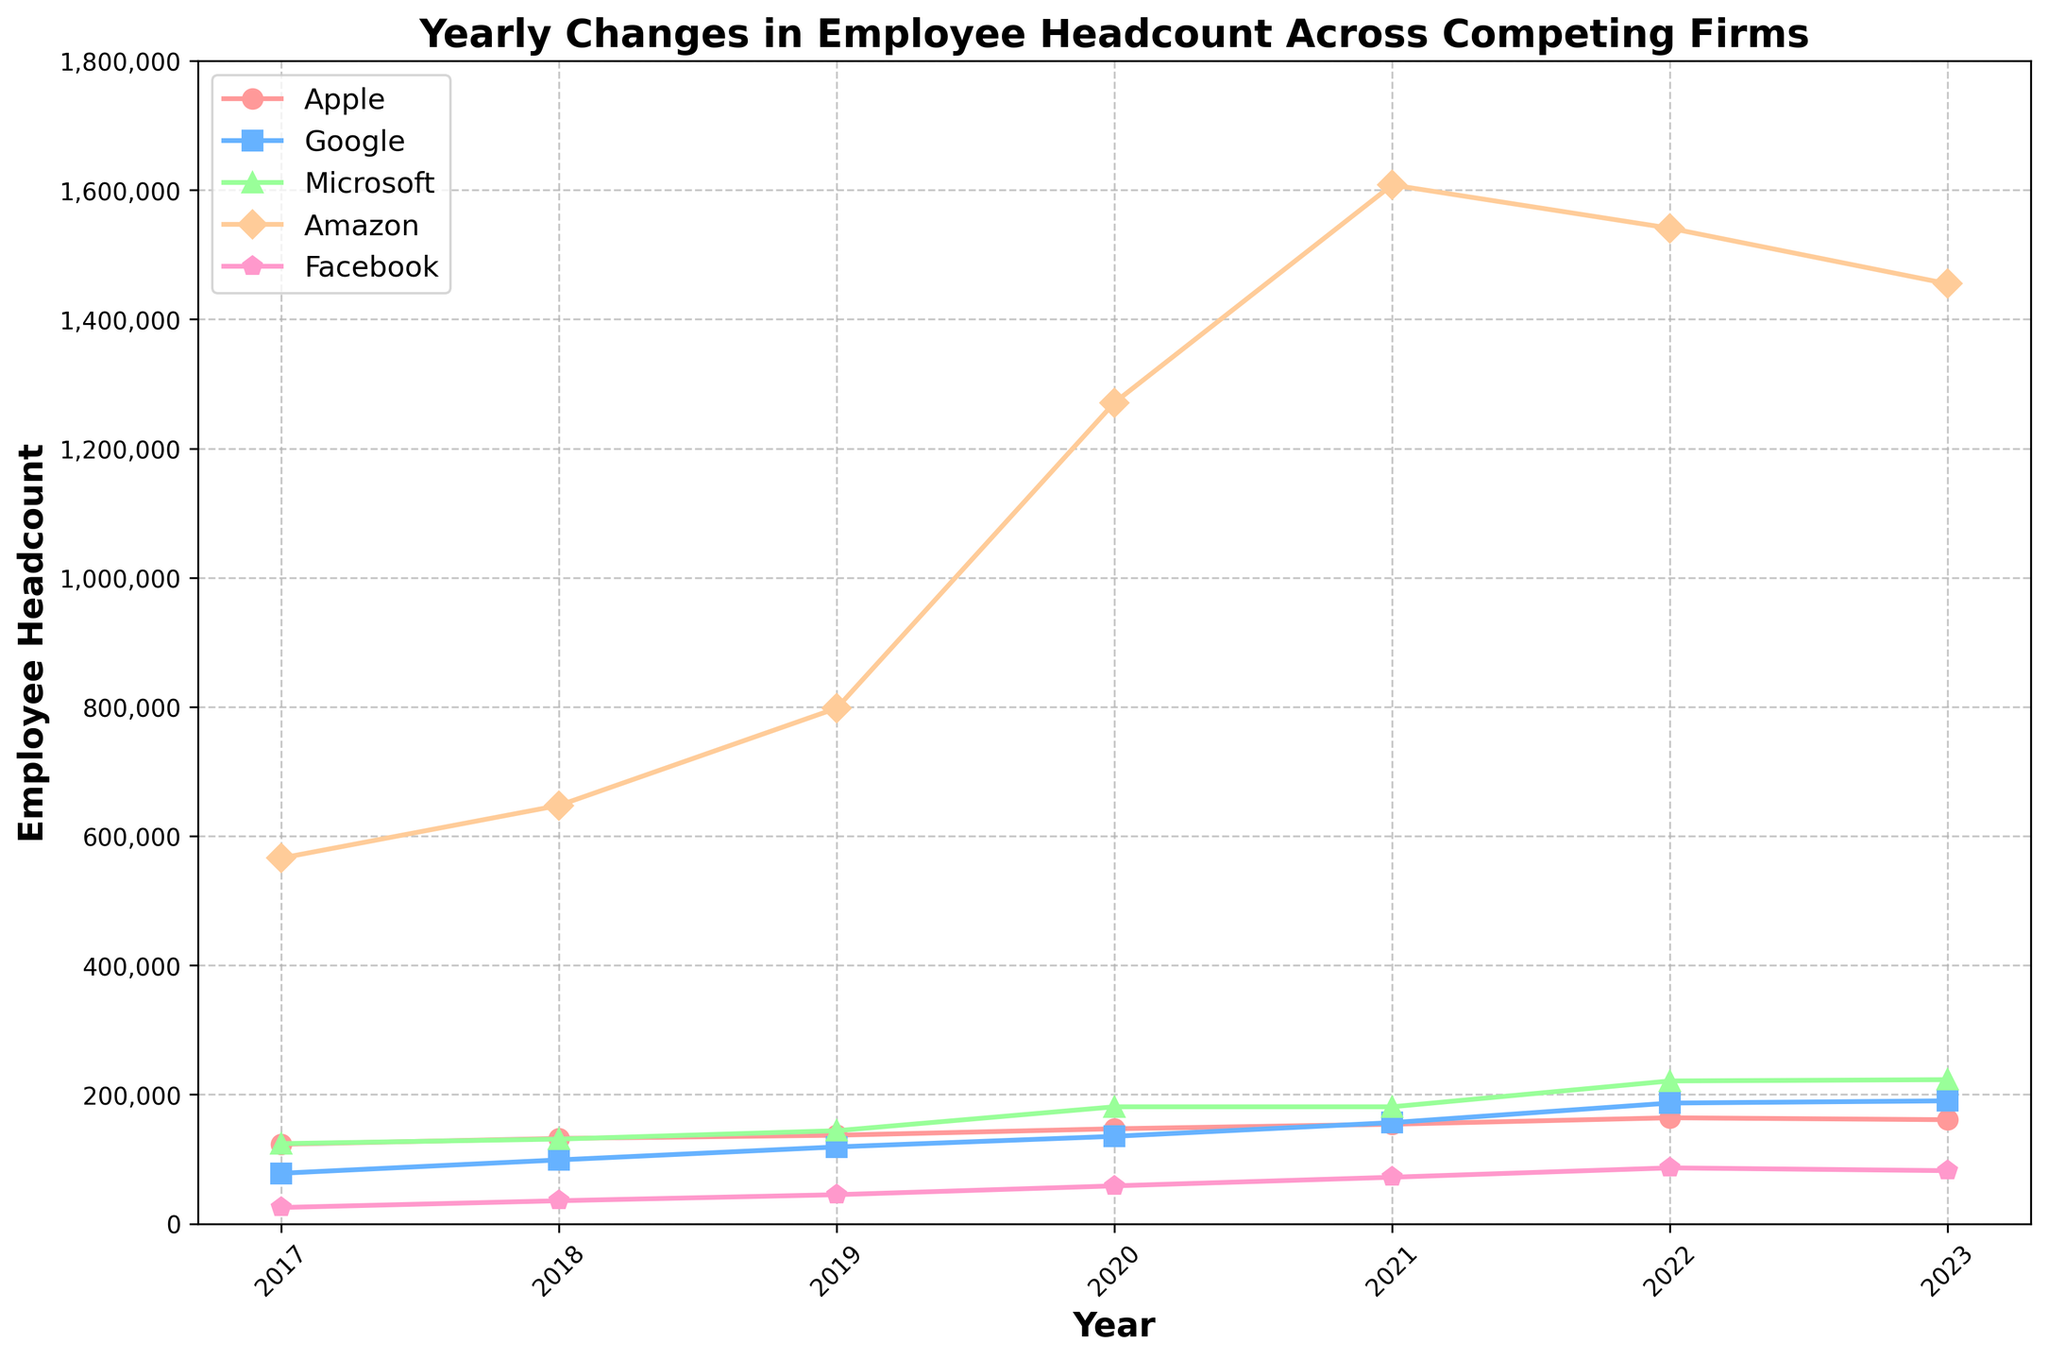Which company had the largest increase in employee headcount from 2018 to 2020? To answer this, subtract the 2018 headcount from the 2020 headcount for each company and find the maximum: Apple (147,000 - 132,000 = 15,000), Google (135,301 - 98,771 = 36,530), Microsoft (181,000 - 131,000 = 50,000), Amazon (1,271,000 - 647,500 = 623,500), Facebook (58,604 - 35,587 = 23,017)
Answer: Amazon How did the headcount for Facebook change from 2022 to 2023? Compare the headcounts of Facebook in 2022 and 2023. The number decreased from 86,482 in 2022 to 82,114 in 2023, so the change is -4,368.
Answer: Decreased by 4,368 Which two companies had the closest headcount in 2019? Compare the headcounts of all companies in 2019 to identify the pair with minimal difference: Apple (137,000), Google (118,899), Microsoft (144,000), Amazon (798,000), Facebook (44,942). The closest pair is Apple and Microsoft, with a difference of 144,000 - 137,000 = 7,000.
Answer: Apple and Microsoft From which year to which year did Amazon see the greatest growth in employee headcount? Calculate the year-over-year growth for Amazon and determine the largest increment: 2017-2018 (81,500), 2018-2019 (150,500), 2019-2020 (472,000), 2020-2021 (337,000), 2021-2022 (-67,000), 2022-2023 (-87,000). The largest growth is 2019-2020.
Answer: 2019 to 2020 What is the total employee headcount for Google over the years provided? Sum the headcounts of Google for each year: 78,101 + 98,771 + 118,899 + 135,301 + 156,500 + 186,779 + 190,234 = 964,585.
Answer: 964,585 Which company had the least fluctuation in employee headcount from 2017 to 2023? Calculate the standard deviation for each company's headcount over the given years and compare: Apple, Google, Microsoft, Amazon, Facebook. The lowest standard deviation corresponds to Apple's relatively stable growth pattern.
Answer: Apple Between 2018 and 2020, did any company see a decline in headcount? Evaluate the difference in headcount for each company from 2018 to 2020: Apple (increase), Google (increase), Microsoft (increase), Amazon (increase), Facebook (increase). None of the companies experienced a decline during this period.
Answer: No What was the approximate average annual growth rate for Amazon from 2017 to 2020? To find the average annual growth rate, calculate the total growth and divide by the number of years: (1,271,000 - 566,000) / (2020 - 2017) = 705,000 / 3 years = 235,000 per year.
Answer: 235,000 per year 